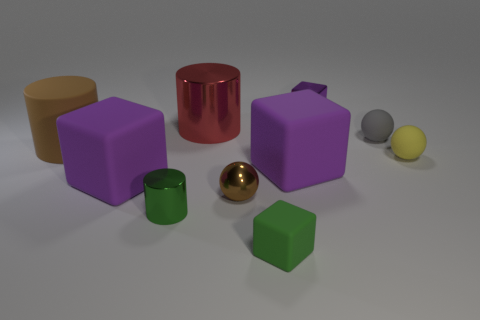Subtract all brown balls. How many balls are left? 2 Subtract all brown cylinders. How many cylinders are left? 2 Subtract 2 cylinders. How many cylinders are left? 1 Subtract all cyan balls. How many purple blocks are left? 3 Subtract all cylinders. How many objects are left? 7 Add 5 gray spheres. How many gray spheres are left? 6 Add 4 metal cylinders. How many metal cylinders exist? 6 Subtract 1 gray spheres. How many objects are left? 9 Subtract all brown spheres. Subtract all cyan blocks. How many spheres are left? 2 Subtract all small cyan matte blocks. Subtract all big red cylinders. How many objects are left? 9 